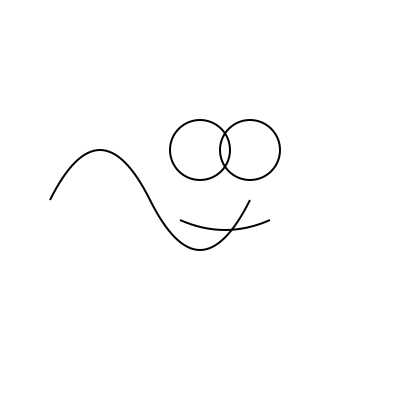Complete the partially drawn line art to reveal a well-known meme character. What is the name of this iconic meme? 1. Analyze the partially drawn line art:
   - Two circular shapes resembling eyes
   - A curved line below, suggesting a smile
   - A wavy line forming part of the head

2. Recognize the distinctive features:
   - Large, circular eyes
   - Simple, curved smile
   - Rounded, blob-like head shape

3. Complete the mental image:
   - Add the rest of the circular head
   - Imagine the character in white with black outlines

4. Identify the meme:
   - This simplistic, childlike drawing style is characteristic of the "Trollface" meme
   - Trollface is known for its mischievous grin and association with internet trolling

5. Recall the meme's cultural significance:
   - Originated in 2008 on 4chan
   - Became widely popular in the early 2010s
   - Often used to represent mischief or sarcasm in online conversations

6. Conclude that this partially drawn line art represents the Trollface meme character.
Answer: Trollface 